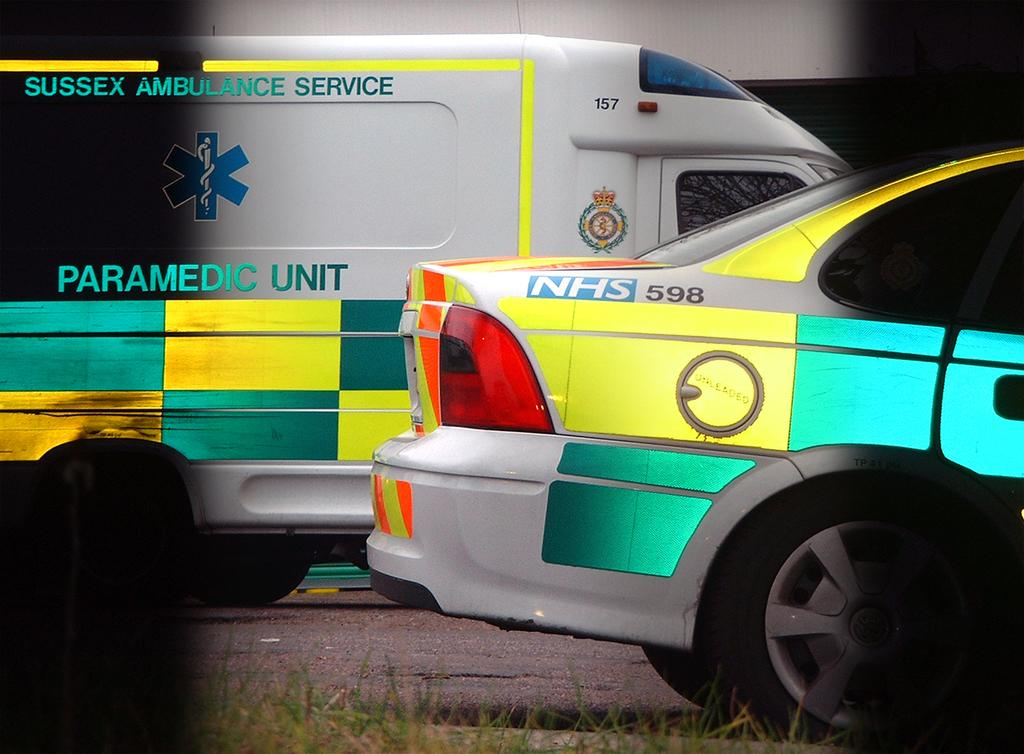Provide a one-sentence caption for the provided image. Ambulance from Sussex Ambulance Service Paramedic Unit next to an offical vehicle NHS 598. 